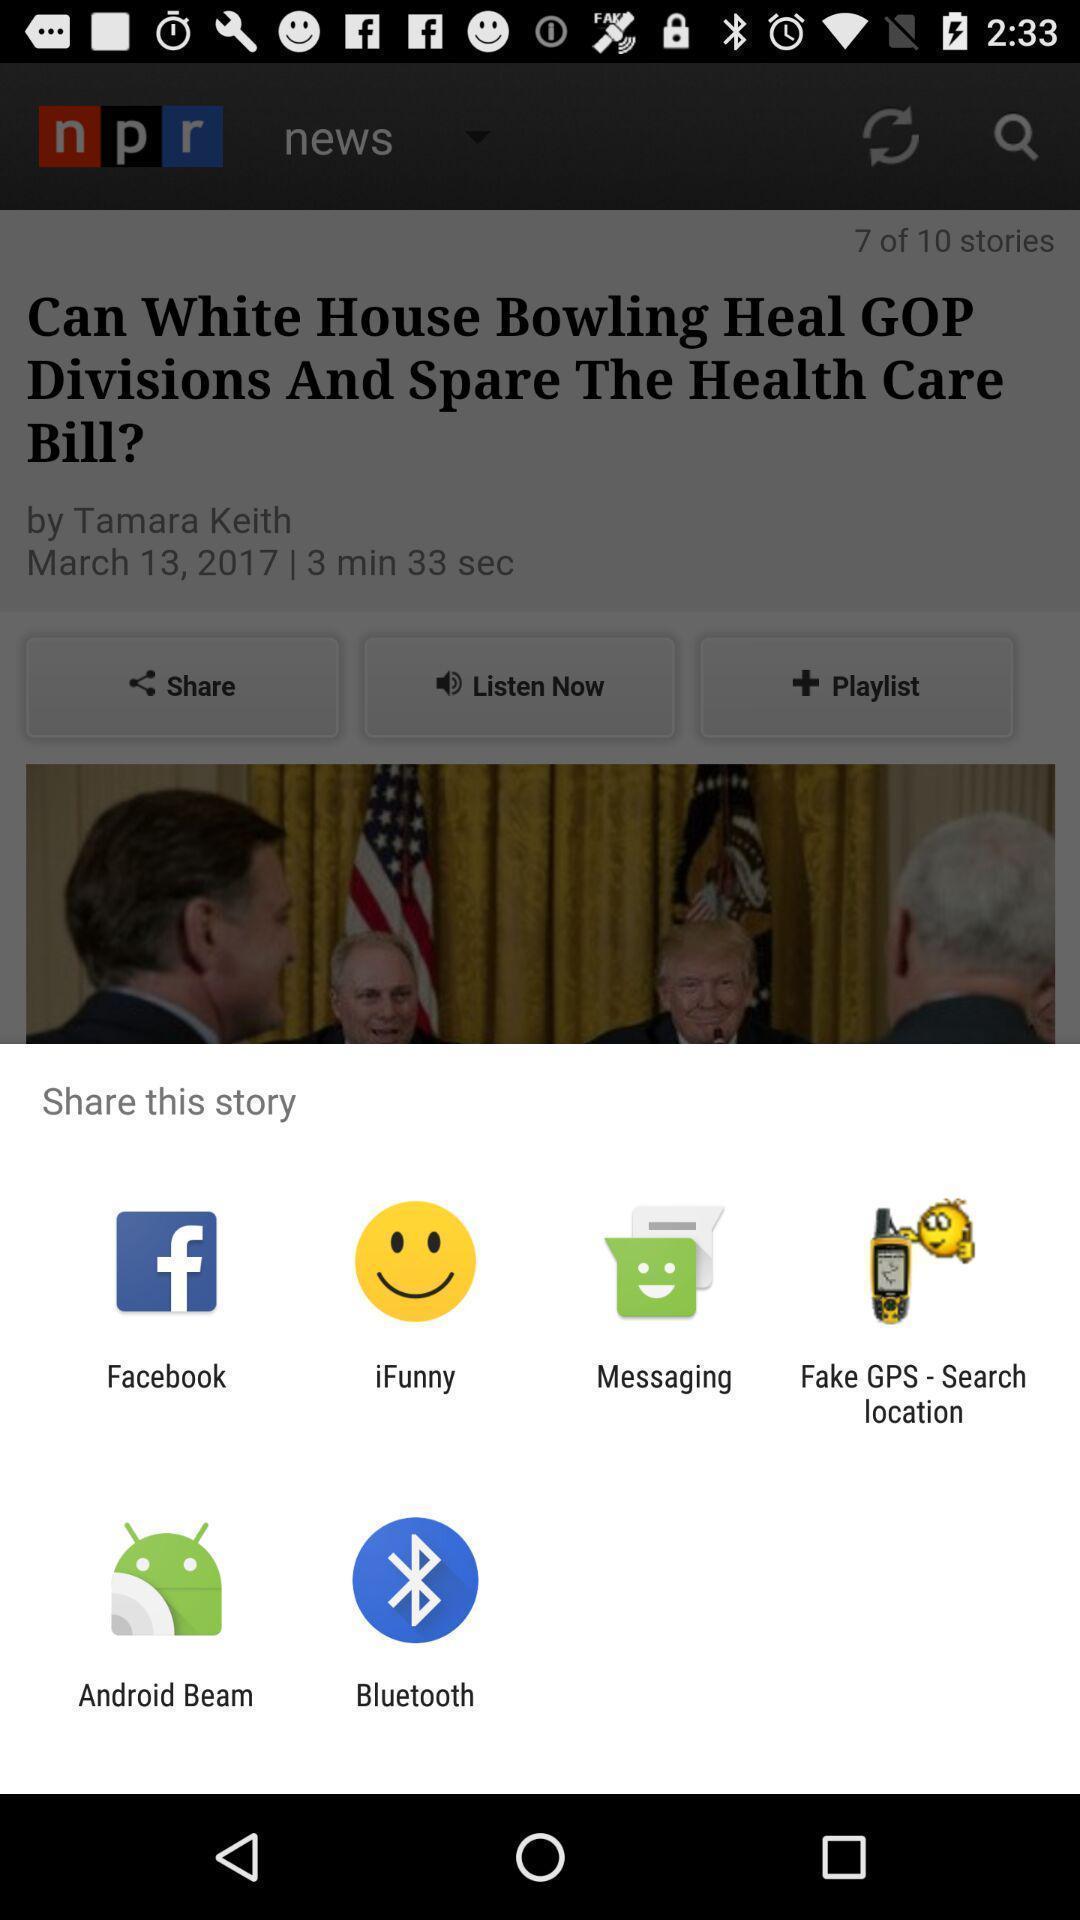Tell me what you see in this picture. Pop-up showing multiple share options. 